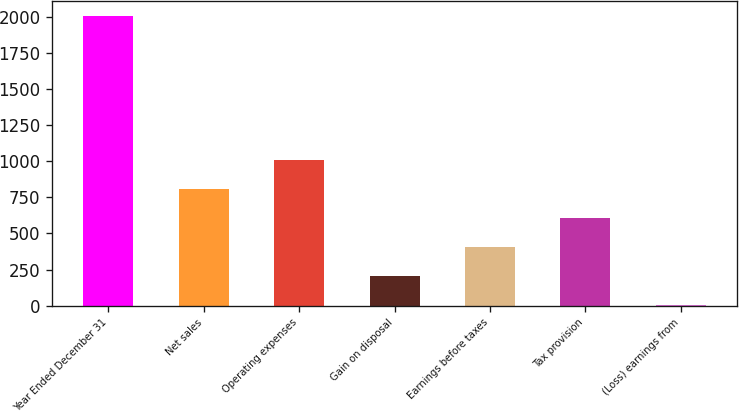Convert chart to OTSL. <chart><loc_0><loc_0><loc_500><loc_500><bar_chart><fcel>Year Ended December 31<fcel>Net sales<fcel>Operating expenses<fcel>Gain on disposal<fcel>Earnings before taxes<fcel>Tax provision<fcel>(Loss) earnings from<nl><fcel>2005<fcel>806.2<fcel>1006<fcel>206.8<fcel>406.6<fcel>606.4<fcel>7<nl></chart> 